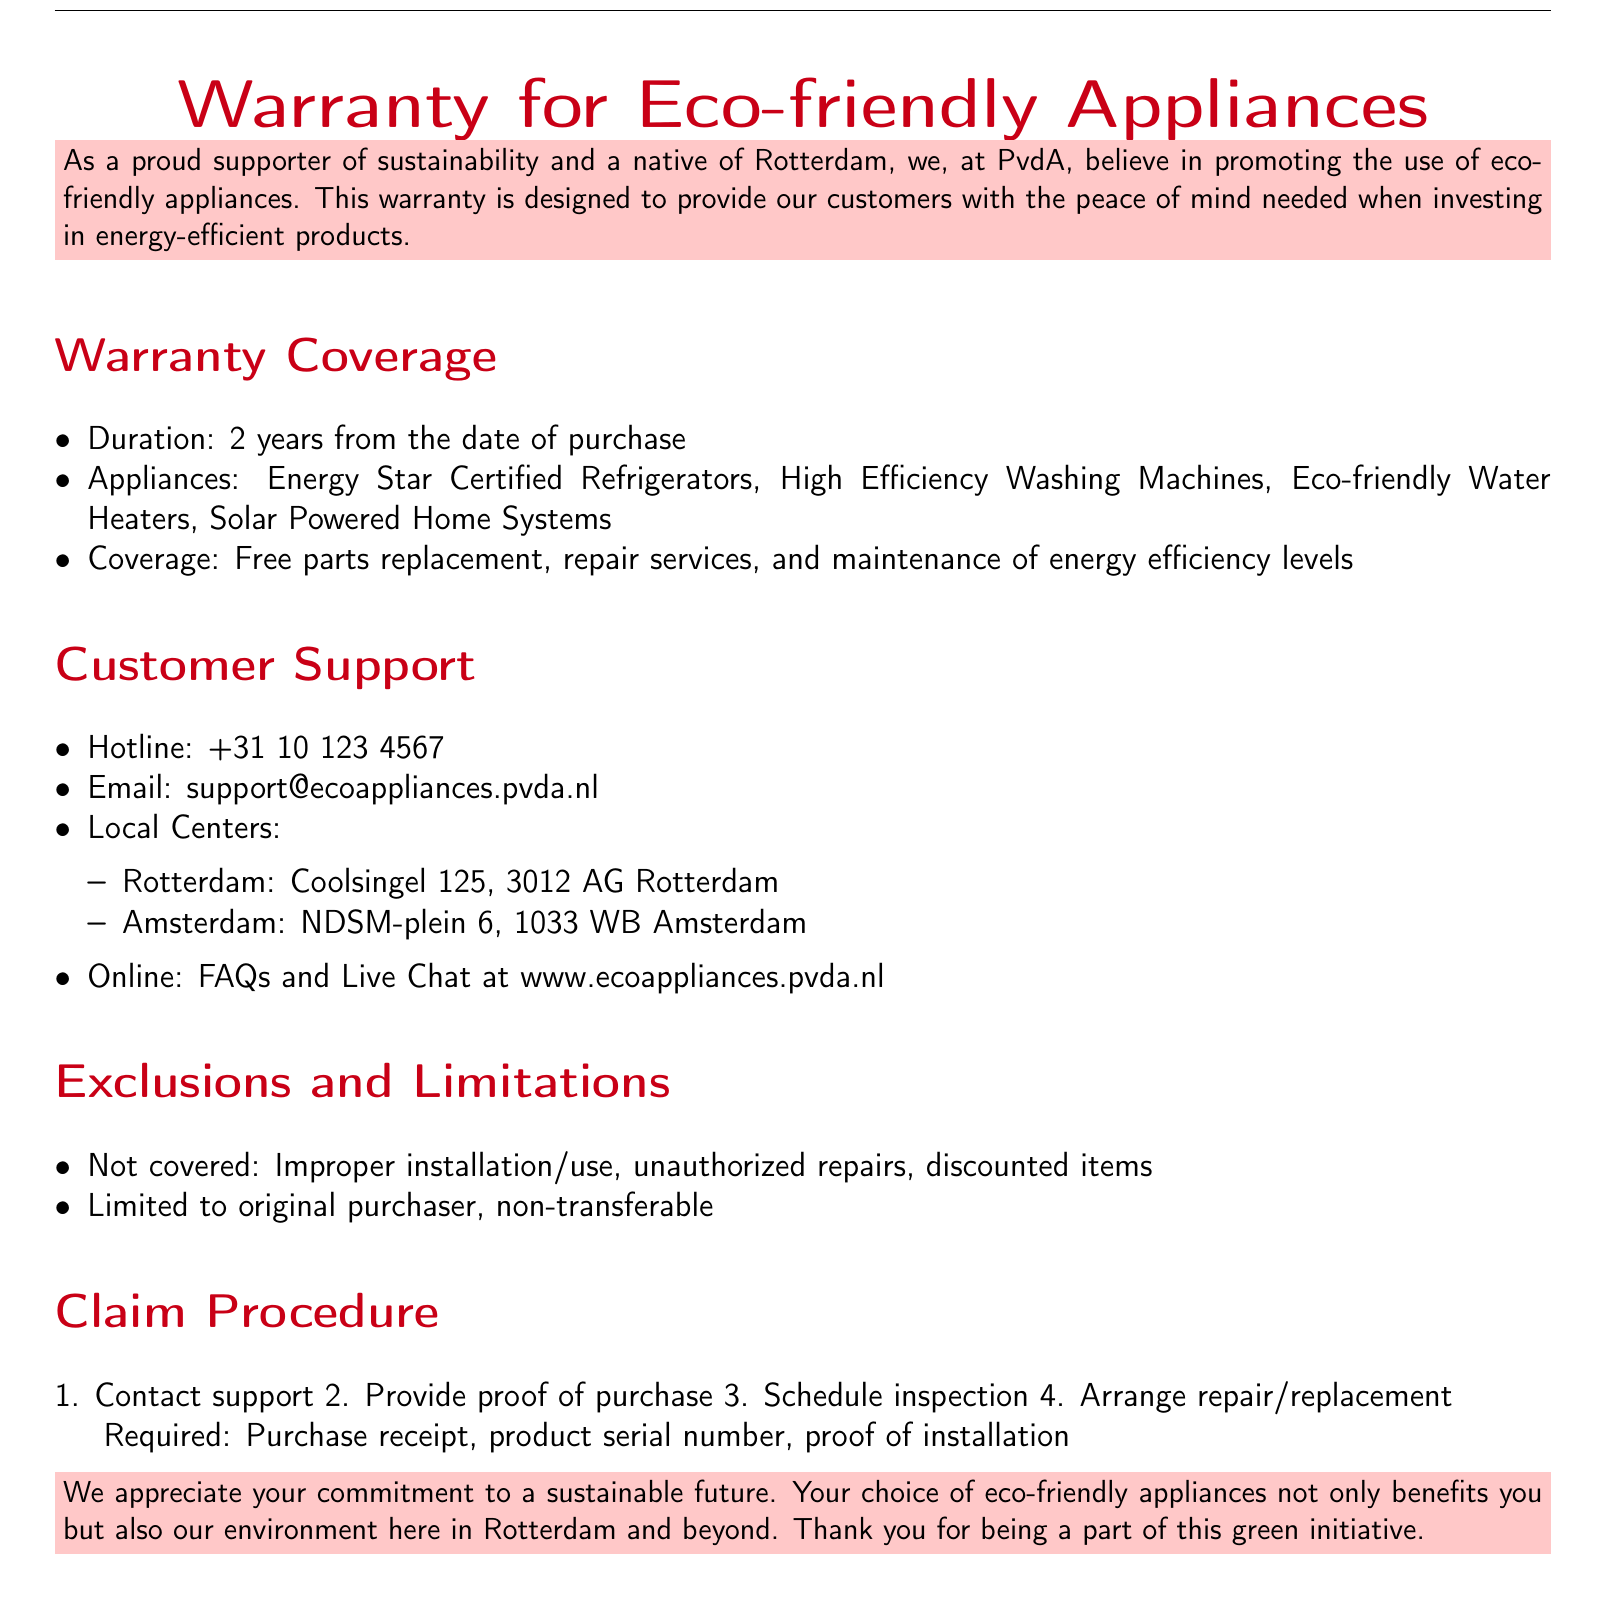What is the duration of the warranty? The duration of the warranty is stated in the document as 2 years from the date of purchase.
Answer: 2 years What appliances are covered under the warranty? The document lists specific types of appliances that are covered under the warranty, including Energy Star Certified Refrigerators.
Answer: Energy Star Certified Refrigerators, High Efficiency Washing Machines, Eco-friendly Water Heaters, Solar Powered Home Systems What is the customer support hotline number? The document provides a specific hotline number for customer support that can be found in the customer support section.
Answer: +31 10 123 4567 Which city has a local customer support center? The document mentions local centers in two cities, and the question is about one of them.
Answer: Rotterdam What must be provided to initiate a claim? The document outlines specific requirements needed to initiate a claim, including proof of purchase.
Answer: Proof of purchase, product serial number, proof of installation What is not covered by the warranty? The document specifies exclusions to the warranty coverage, including certain circumstances under which claims cannot be made.
Answer: Improper installation/use, unauthorized repairs, discounted items How can customers contact support online? The document indicates options for online support, specifically mentioning an available service related to customer queries.
Answer: FAQs and Live Chat at www.ecoappliances.pvda.nl Is the warranty transferable? The document explicitly states the terms under which the warranty applies, particularly regarding who it is limited to.
Answer: Non-transferable 